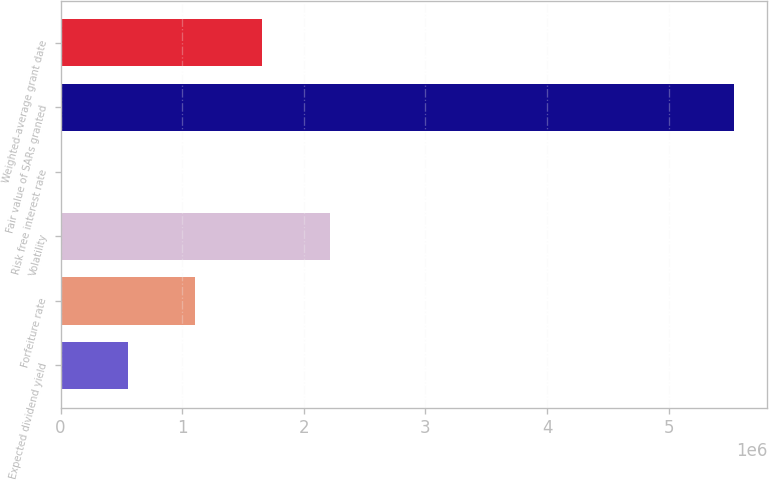Convert chart to OTSL. <chart><loc_0><loc_0><loc_500><loc_500><bar_chart><fcel>Expected dividend yield<fcel>Forfeiture rate<fcel>Volatility<fcel>Risk free interest rate<fcel>Fair value of SARs granted<fcel>Weighted-average grant date<nl><fcel>553301<fcel>1.1066e+06<fcel>2.2132e+06<fcel>0.94<fcel>5.533e+06<fcel>1.6599e+06<nl></chart> 